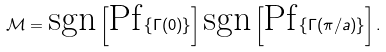Convert formula to latex. <formula><loc_0><loc_0><loc_500><loc_500>\mathcal { M } = \text {sgn} \left [ \text {Pf} \left \{ \Gamma ( 0 ) \right \} \right ] \text {sgn} \left [ \text {Pf} \left \{ \Gamma ( \pi / a ) \right \} \right ] .</formula> 